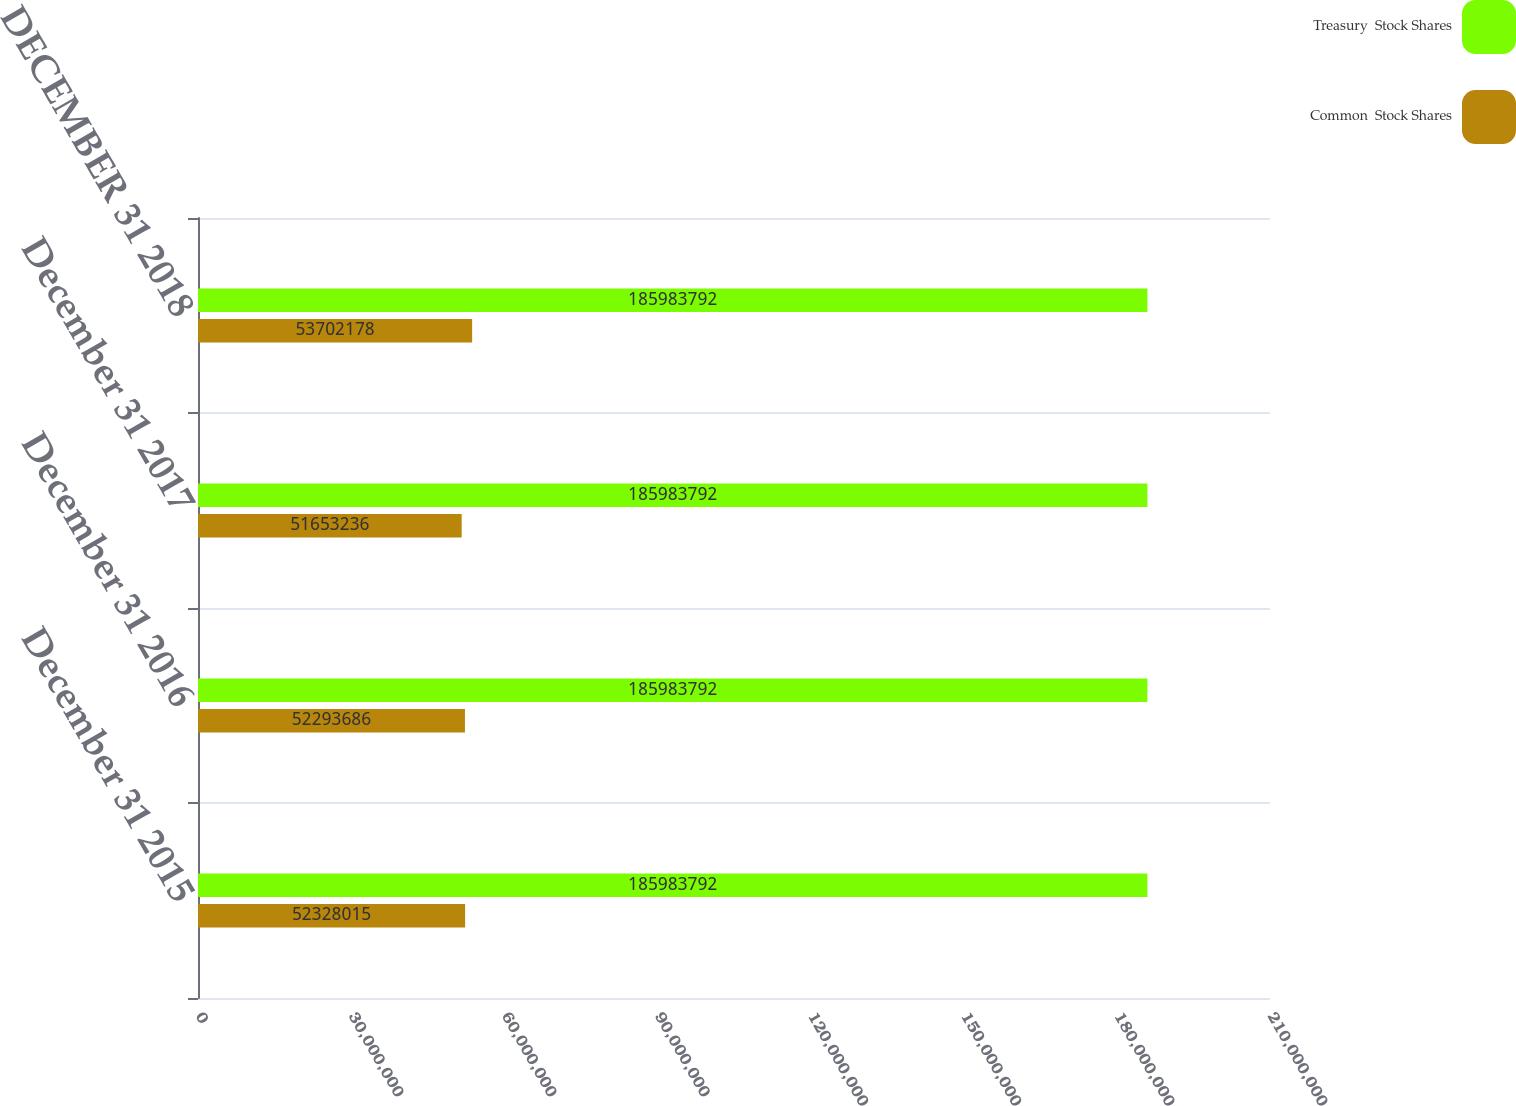<chart> <loc_0><loc_0><loc_500><loc_500><stacked_bar_chart><ecel><fcel>December 31 2015<fcel>December 31 2016<fcel>December 31 2017<fcel>DECEMBER 31 2018<nl><fcel>Treasury  Stock Shares<fcel>1.85984e+08<fcel>1.85984e+08<fcel>1.85984e+08<fcel>1.85984e+08<nl><fcel>Common  Stock Shares<fcel>5.2328e+07<fcel>5.22937e+07<fcel>5.16532e+07<fcel>5.37022e+07<nl></chart> 